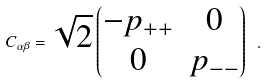<formula> <loc_0><loc_0><loc_500><loc_500>C _ { \alpha \beta } = \sqrt { 2 } \begin{pmatrix} - p _ { + + } & 0 \\ 0 & p _ { - - } \end{pmatrix} \ .</formula> 